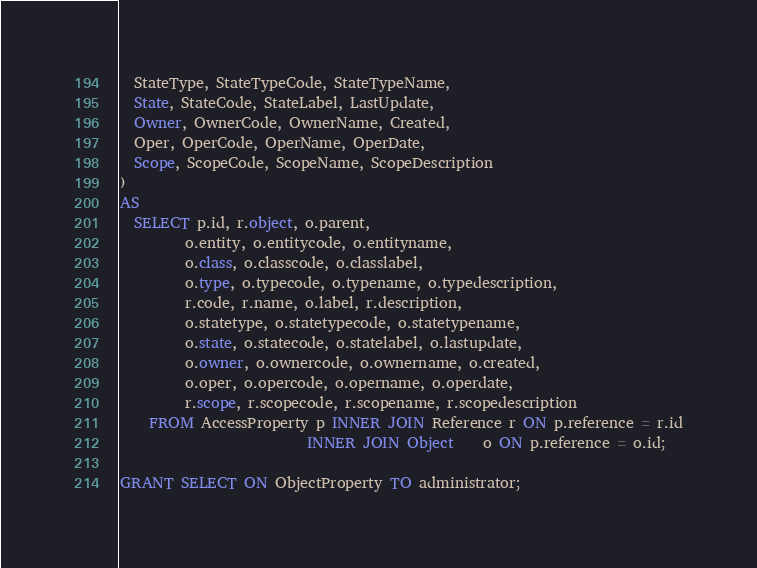<code> <loc_0><loc_0><loc_500><loc_500><_SQL_>  StateType, StateTypeCode, StateTypeName,
  State, StateCode, StateLabel, LastUpdate,
  Owner, OwnerCode, OwnerName, Created,
  Oper, OperCode, OperName, OperDate,
  Scope, ScopeCode, ScopeName, ScopeDescription
)
AS
  SELECT p.id, r.object, o.parent,
         o.entity, o.entitycode, o.entityname,
         o.class, o.classcode, o.classlabel,
         o.type, o.typecode, o.typename, o.typedescription,
         r.code, r.name, o.label, r.description,
         o.statetype, o.statetypecode, o.statetypename,
         o.state, o.statecode, o.statelabel, o.lastupdate,
         o.owner, o.ownercode, o.ownername, o.created,
         o.oper, o.opercode, o.opername, o.operdate,
         r.scope, r.scopecode, r.scopename, r.scopedescription
    FROM AccessProperty p INNER JOIN Reference r ON p.reference = r.id
                          INNER JOIN Object    o ON p.reference = o.id;

GRANT SELECT ON ObjectProperty TO administrator;
</code> 